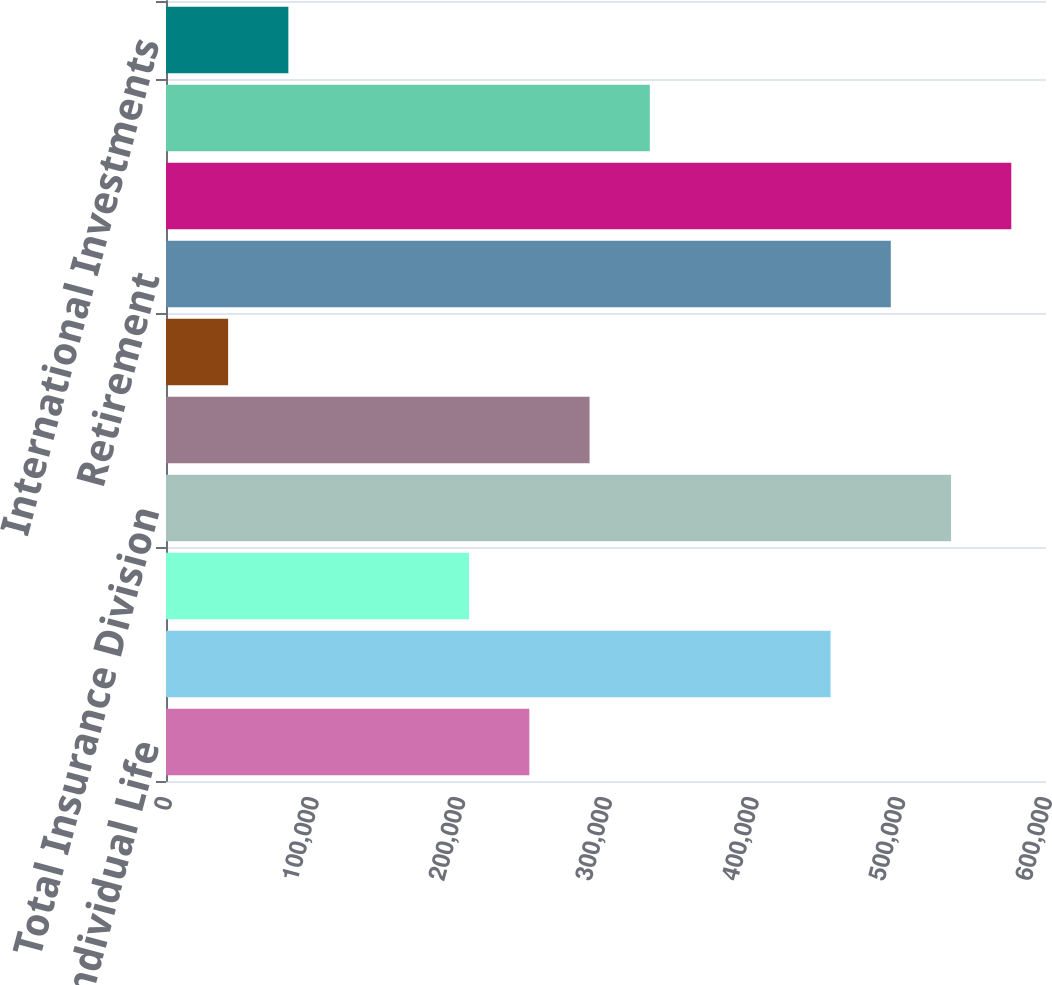Convert chart. <chart><loc_0><loc_0><loc_500><loc_500><bar_chart><fcel>Individual Life<fcel>Individual Annuities<fcel>Group Insurance<fcel>Total Insurance Division<fcel>Asset Management<fcel>Financial Advisory<fcel>Retirement<fcel>Total Investment Division<fcel>International Insurance<fcel>International Investments<nl><fcel>247731<fcel>453106<fcel>206656<fcel>535256<fcel>288806<fcel>42356<fcel>494181<fcel>576331<fcel>329881<fcel>83431<nl></chart> 